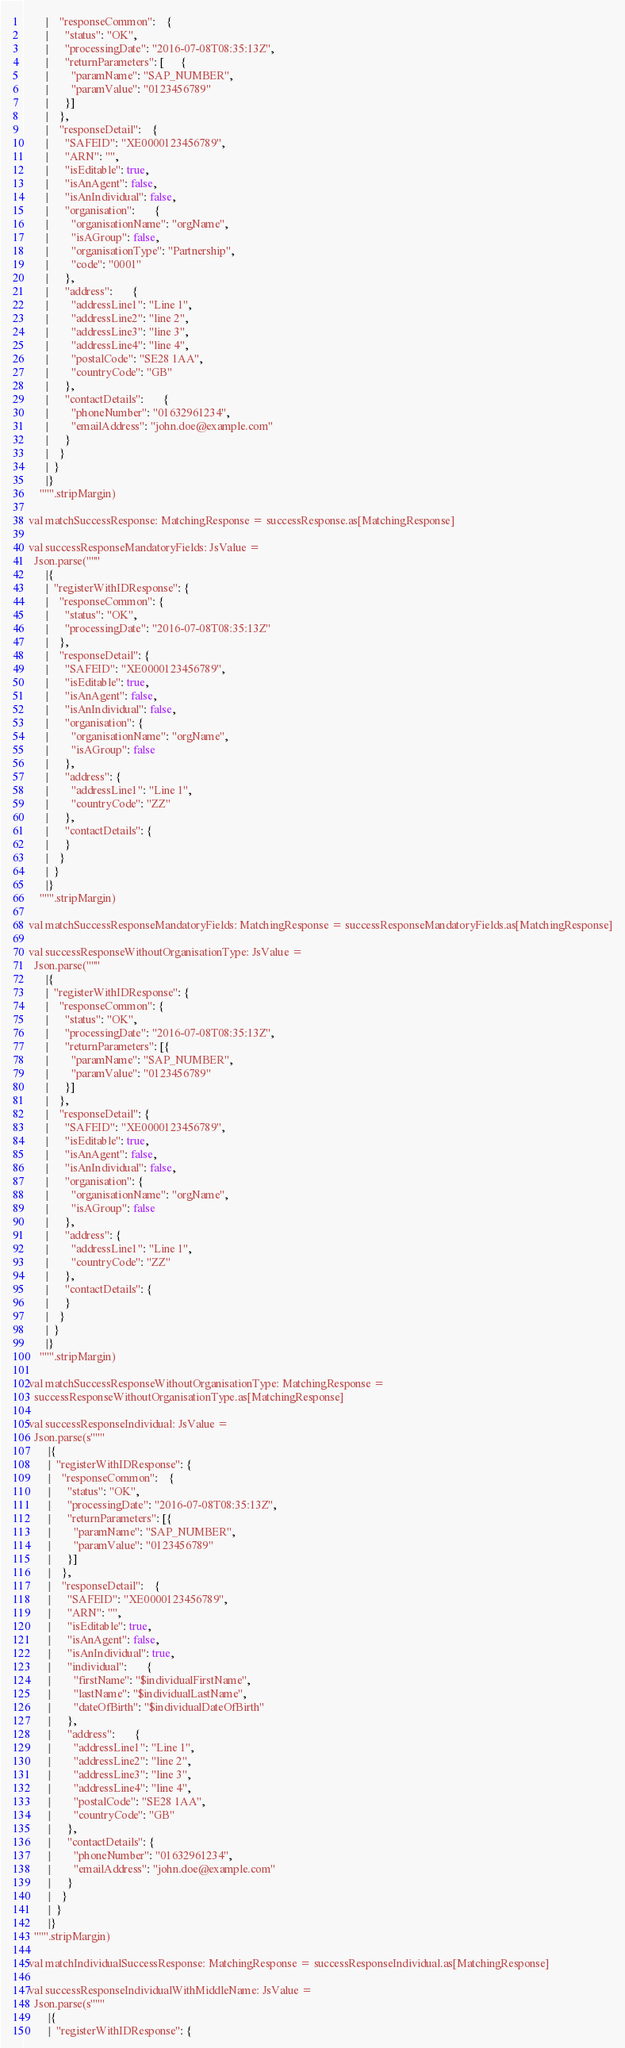<code> <loc_0><loc_0><loc_500><loc_500><_Scala_>        |    "responseCommon":    {
        |      "status": "OK",
        |      "processingDate": "2016-07-08T08:35:13Z",
        |      "returnParameters": [      {
        |        "paramName": "SAP_NUMBER",
        |        "paramValue": "0123456789"
        |      }]
        |    },
        |    "responseDetail":    {
        |      "SAFEID": "XE0000123456789",
        |      "ARN": "",
        |      "isEditable": true,
        |      "isAnAgent": false,
        |      "isAnIndividual": false,
        |      "organisation":       {
        |        "organisationName": "orgName",
        |        "isAGroup": false,
        |        "organisationType": "Partnership",
        |        "code": "0001"
        |      },
        |      "address":       {
        |        "addressLine1": "Line 1",
        |        "addressLine2": "line 2",
        |        "addressLine3": "line 3",
        |        "addressLine4": "line 4",
        |        "postalCode": "SE28 1AA",
        |        "countryCode": "GB"
        |      },
        |      "contactDetails":       {
        |        "phoneNumber": "01632961234",
        |        "emailAddress": "john.doe@example.com"
        |      }
        |    }
        |  }
        |}
      """.stripMargin)

  val matchSuccessResponse: MatchingResponse = successResponse.as[MatchingResponse]

  val successResponseMandatoryFields: JsValue =
    Json.parse("""
        |{
        |  "registerWithIDResponse": {
        |    "responseCommon": {
        |      "status": "OK",
        |      "processingDate": "2016-07-08T08:35:13Z"
        |    },
        |    "responseDetail": {
        |      "SAFEID": "XE0000123456789",
        |      "isEditable": true,
        |      "isAnAgent": false,
        |      "isAnIndividual": false,
        |      "organisation": {
        |        "organisationName": "orgName",
        |        "isAGroup": false
        |      },
        |      "address": {
        |        "addressLine1": "Line 1",
        |        "countryCode": "ZZ"
        |      },
        |      "contactDetails": {
        |      }
        |    }
        |  }
        |}
      """.stripMargin)

  val matchSuccessResponseMandatoryFields: MatchingResponse = successResponseMandatoryFields.as[MatchingResponse]

  val successResponseWithoutOrganisationType: JsValue =
    Json.parse("""
        |{
        |  "registerWithIDResponse": {
        |    "responseCommon": {
        |      "status": "OK",
        |      "processingDate": "2016-07-08T08:35:13Z",
        |      "returnParameters": [{
        |        "paramName": "SAP_NUMBER",
        |        "paramValue": "0123456789"
        |      }]
        |    },
        |    "responseDetail": {
        |      "SAFEID": "XE0000123456789",
        |      "isEditable": true,
        |      "isAnAgent": false,
        |      "isAnIndividual": false,
        |      "organisation": {
        |        "organisationName": "orgName",
        |        "isAGroup": false
        |      },
        |      "address": {
        |        "addressLine1": "Line 1",
        |        "countryCode": "ZZ"
        |      },
        |      "contactDetails": {
        |      }
        |    }
        |  }
        |}
      """.stripMargin)

  val matchSuccessResponseWithoutOrganisationType: MatchingResponse =
    successResponseWithoutOrganisationType.as[MatchingResponse]

  val successResponseIndividual: JsValue =
    Json.parse(s"""
         |{
         |  "registerWithIDResponse": {
         |    "responseCommon":    {
         |      "status": "OK",
         |      "processingDate": "2016-07-08T08:35:13Z",
         |      "returnParameters": [{
         |        "paramName": "SAP_NUMBER",
         |        "paramValue": "0123456789"
         |      }]
         |    },
         |    "responseDetail":    {
         |      "SAFEID": "XE0000123456789",
         |      "ARN": "",
         |      "isEditable": true,
         |      "isAnAgent": false,
         |      "isAnIndividual": true,
         |      "individual":       {
         |        "firstName": "$individualFirstName",
         |        "lastName": "$individualLastName",
         |        "dateOfBirth": "$individualDateOfBirth"
         |      },
         |      "address":       {
         |        "addressLine1": "Line 1",
         |        "addressLine2": "line 2",
         |        "addressLine3": "line 3",
         |        "addressLine4": "line 4",
         |        "postalCode": "SE28 1AA",
         |        "countryCode": "GB"
         |      },
         |      "contactDetails": {
         |        "phoneNumber": "01632961234",
         |        "emailAddress": "john.doe@example.com"
         |      }
         |    }
         |  }
         |}
    """.stripMargin)

  val matchIndividualSuccessResponse: MatchingResponse = successResponseIndividual.as[MatchingResponse]

  val successResponseIndividualWithMiddleName: JsValue =
    Json.parse(s"""
         |{
         |  "registerWithIDResponse": {</code> 